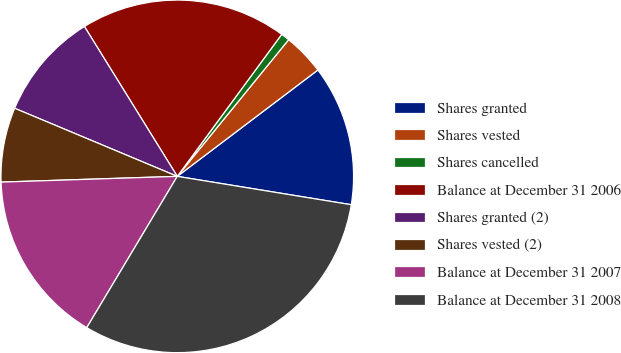<chart> <loc_0><loc_0><loc_500><loc_500><pie_chart><fcel>Shares granted<fcel>Shares vested<fcel>Shares cancelled<fcel>Balance at December 31 2006<fcel>Shares granted (2)<fcel>Shares vested (2)<fcel>Balance at December 31 2007<fcel>Balance at December 31 2008<nl><fcel>12.88%<fcel>3.81%<fcel>0.79%<fcel>18.92%<fcel>9.86%<fcel>6.83%<fcel>15.9%<fcel>31.01%<nl></chart> 